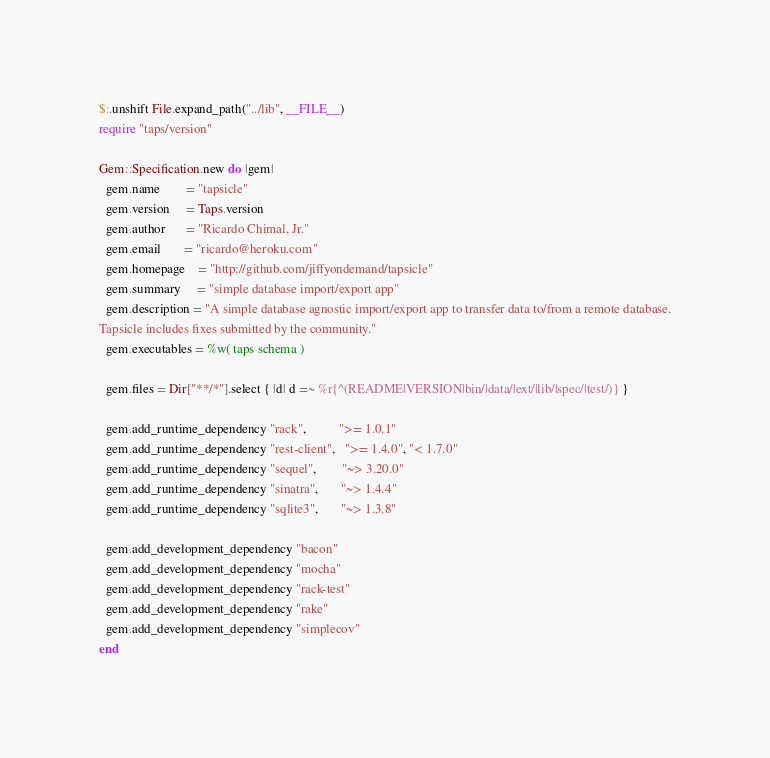<code> <loc_0><loc_0><loc_500><loc_500><_Ruby_>$:.unshift File.expand_path("../lib", __FILE__)
require "taps/version"

Gem::Specification.new do |gem|
  gem.name        = "tapsicle"
  gem.version     = Taps.version
  gem.author      = "Ricardo Chimal, Jr."
  gem.email       = "ricardo@heroku.com"
  gem.homepage    = "http://github.com/jiffyondemand/tapsicle"
  gem.summary     = "simple database import/export app"
  gem.description = "A simple database agnostic import/export app to transfer data to/from a remote database.
Tapsicle includes fixes submitted by the community."
  gem.executables = %w( taps schema )

  gem.files = Dir["**/*"].select { |d| d =~ %r{^(README|VERSION|bin/|data/|ext/|lib/|spec/|test/)} }

  gem.add_runtime_dependency "rack",          ">= 1.0.1"
  gem.add_runtime_dependency "rest-client",   ">= 1.4.0", "< 1.7.0"
  gem.add_runtime_dependency "sequel",        "~> 3.20.0"
  gem.add_runtime_dependency "sinatra",       "~> 1.4.4"
  gem.add_runtime_dependency "sqlite3",       "~> 1.3.8"

  gem.add_development_dependency "bacon"
  gem.add_development_dependency "mocha"
  gem.add_development_dependency "rack-test"
  gem.add_development_dependency "rake"
  gem.add_development_dependency "simplecov"
end

</code> 